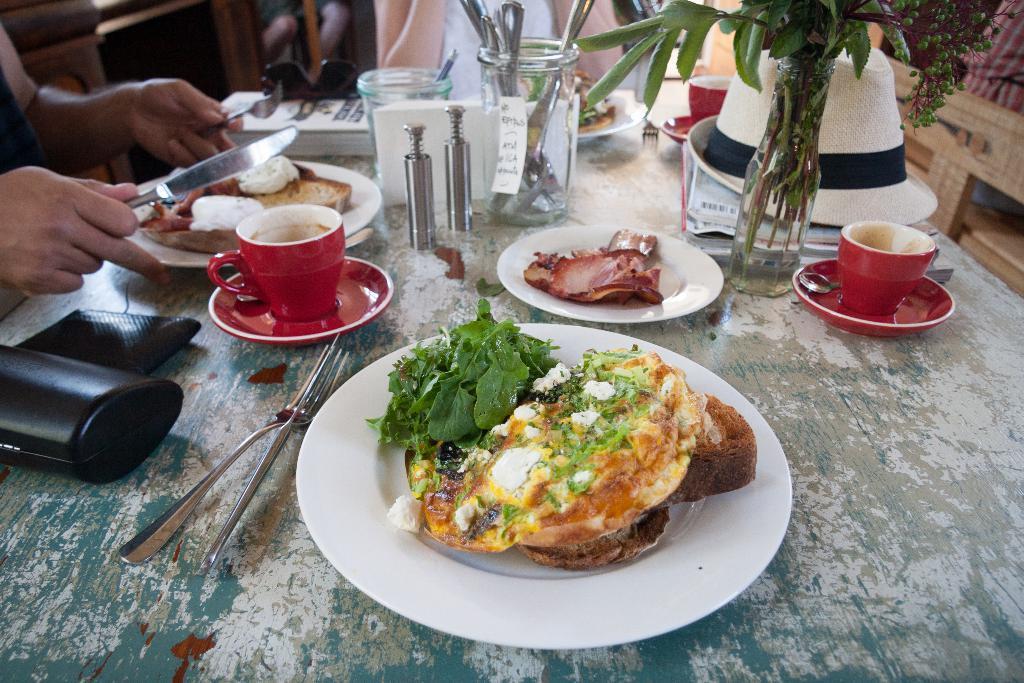Describe this image in one or two sentences. This picture shows a couple of people seated and we see food and the plates on the table and we see tea cups and a plant and a hat and forks and a knife on the table and we see a person holding a knife in his hand in order to take his food 